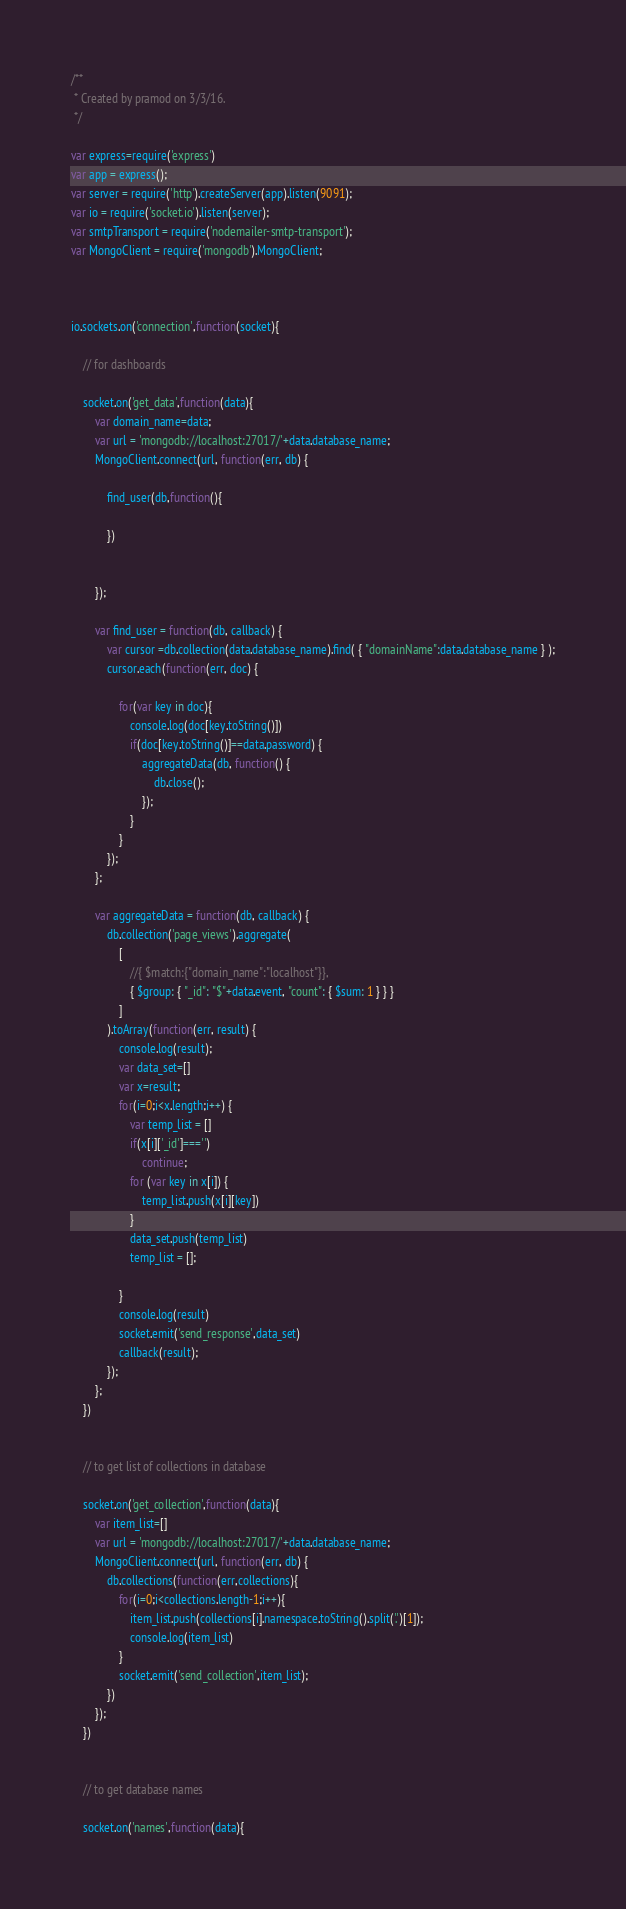<code> <loc_0><loc_0><loc_500><loc_500><_JavaScript_>/**
 * Created by pramod on 3/3/16.
 */

var express=require('express')
var app = express();
var server = require('http').createServer(app).listen(9091);
var io = require('socket.io').listen(server);
var smtpTransport = require('nodemailer-smtp-transport');
var MongoClient = require('mongodb').MongoClient;



io.sockets.on('connection',function(socket){

    // for dashboards

    socket.on('get_data',function(data){
        var domain_name=data;
        var url = 'mongodb://localhost:27017/'+data.database_name;
        MongoClient.connect(url, function(err, db) {

            find_user(db,function(){

            })


        });

        var find_user = function(db, callback) {
            var cursor =db.collection(data.database_name).find( { "domainName":data.database_name } );
            cursor.each(function(err, doc) {

                for(var key in doc){
                    console.log(doc[key.toString()])
                    if(doc[key.toString()]==data.password) {
                        aggregateData(db, function() {
                            db.close();
                        });
                    }
                }
            });
        };

        var aggregateData = function(db, callback) {
            db.collection('page_views').aggregate(
                [
                    //{ $match:{"domain_name":"localhost"}},
                    { $group: { "_id": "$"+data.event, "count": { $sum: 1 } } }
                ]
            ).toArray(function(err, result) {
                console.log(result);
                var data_set=[]
                var x=result;
                for(i=0;i<x.length;i++) {
                    var temp_list = []
                    if(x[i]['_id']==='')
                        continue;
                    for (var key in x[i]) {
                        temp_list.push(x[i][key])
                    }
                    data_set.push(temp_list)
                    temp_list = [];

                }
                console.log(result)
                socket.emit('send_response',data_set)
                callback(result);
            });
        };
    })


    // to get list of collections in database

    socket.on('get_collection',function(data){
        var item_list=[]
        var url = 'mongodb://localhost:27017/'+data.database_name;
        MongoClient.connect(url, function(err, db) {
            db.collections(function(err,collections){
                for(i=0;i<collections.length-1;i++){
                    item_list.push(collections[i].namespace.toString().split('.')[1]);
                    console.log(item_list)
                }
                socket.emit('send_collection',item_list);
            })
        });
    })


    // to get database names

    socket.on('names',function(data){</code> 